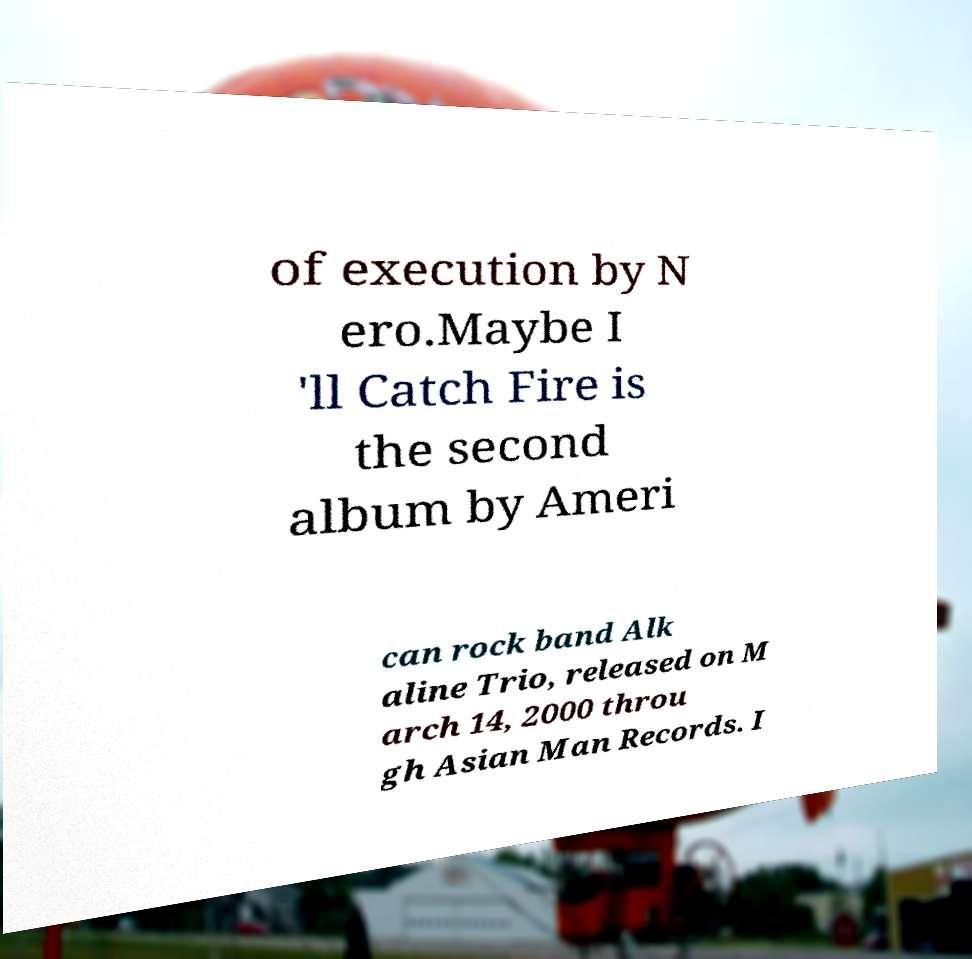What messages or text are displayed in this image? I need them in a readable, typed format. of execution by N ero.Maybe I 'll Catch Fire is the second album by Ameri can rock band Alk aline Trio, released on M arch 14, 2000 throu gh Asian Man Records. I 